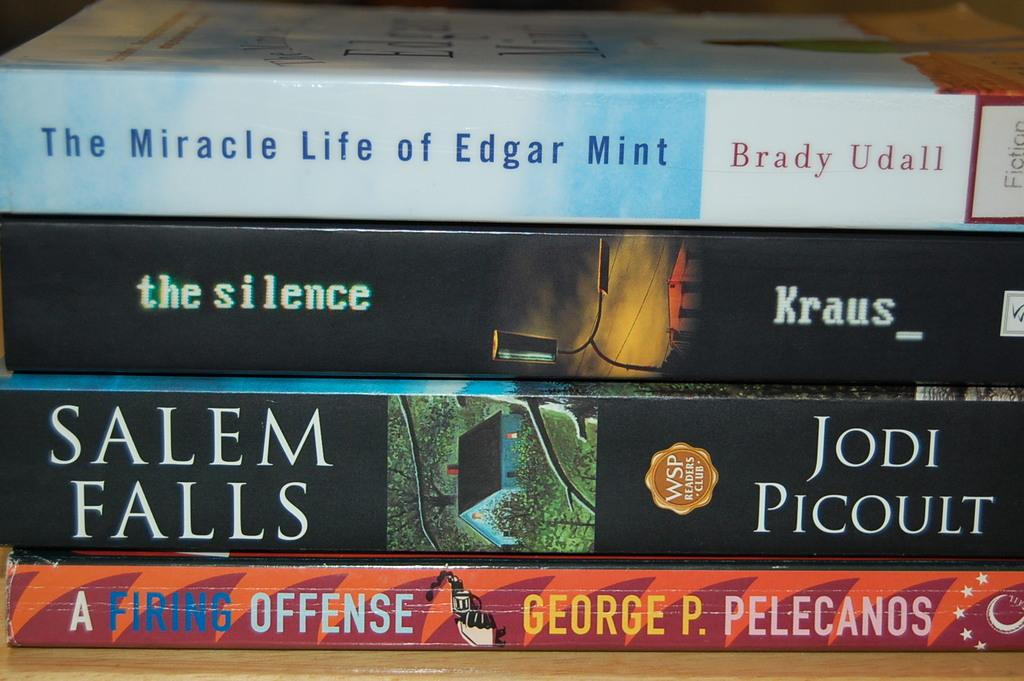Provide a one-sentence caption for the provided image. Four paperback books are stacks, one by Brady Udall on top. 